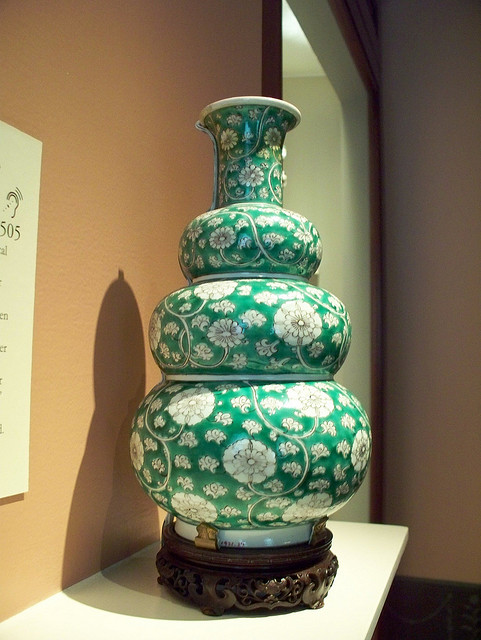Please transcribe the text in this image. 505 